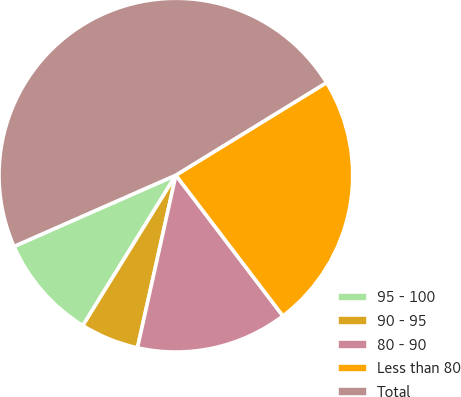Convert chart to OTSL. <chart><loc_0><loc_0><loc_500><loc_500><pie_chart><fcel>95 - 100<fcel>90 - 95<fcel>80 - 90<fcel>Less than 80<fcel>Total<nl><fcel>9.58%<fcel>5.33%<fcel>13.83%<fcel>23.42%<fcel>47.83%<nl></chart> 